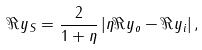<formula> <loc_0><loc_0><loc_500><loc_500>\Re y _ { S } = \frac { 2 } { 1 + \eta } \left | \eta \Re y _ { o } - \Re y _ { i } \right | ,</formula> 